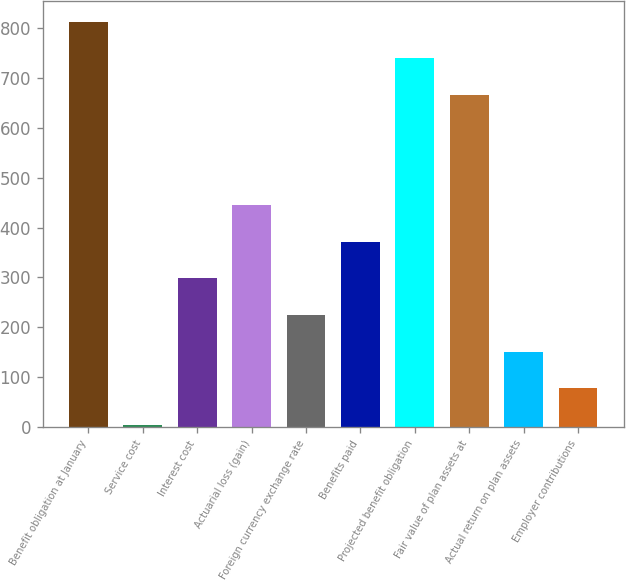Convert chart to OTSL. <chart><loc_0><loc_0><loc_500><loc_500><bar_chart><fcel>Benefit obligation at January<fcel>Service cost<fcel>Interest cost<fcel>Actuarial loss (gain)<fcel>Foreign currency exchange rate<fcel>Benefits paid<fcel>Projected benefit obligation<fcel>Fair value of plan assets at<fcel>Actual return on plan assets<fcel>Employer contributions<nl><fcel>812.59<fcel>4.2<fcel>298.16<fcel>445.14<fcel>224.67<fcel>371.65<fcel>739.1<fcel>665.61<fcel>151.18<fcel>77.69<nl></chart> 